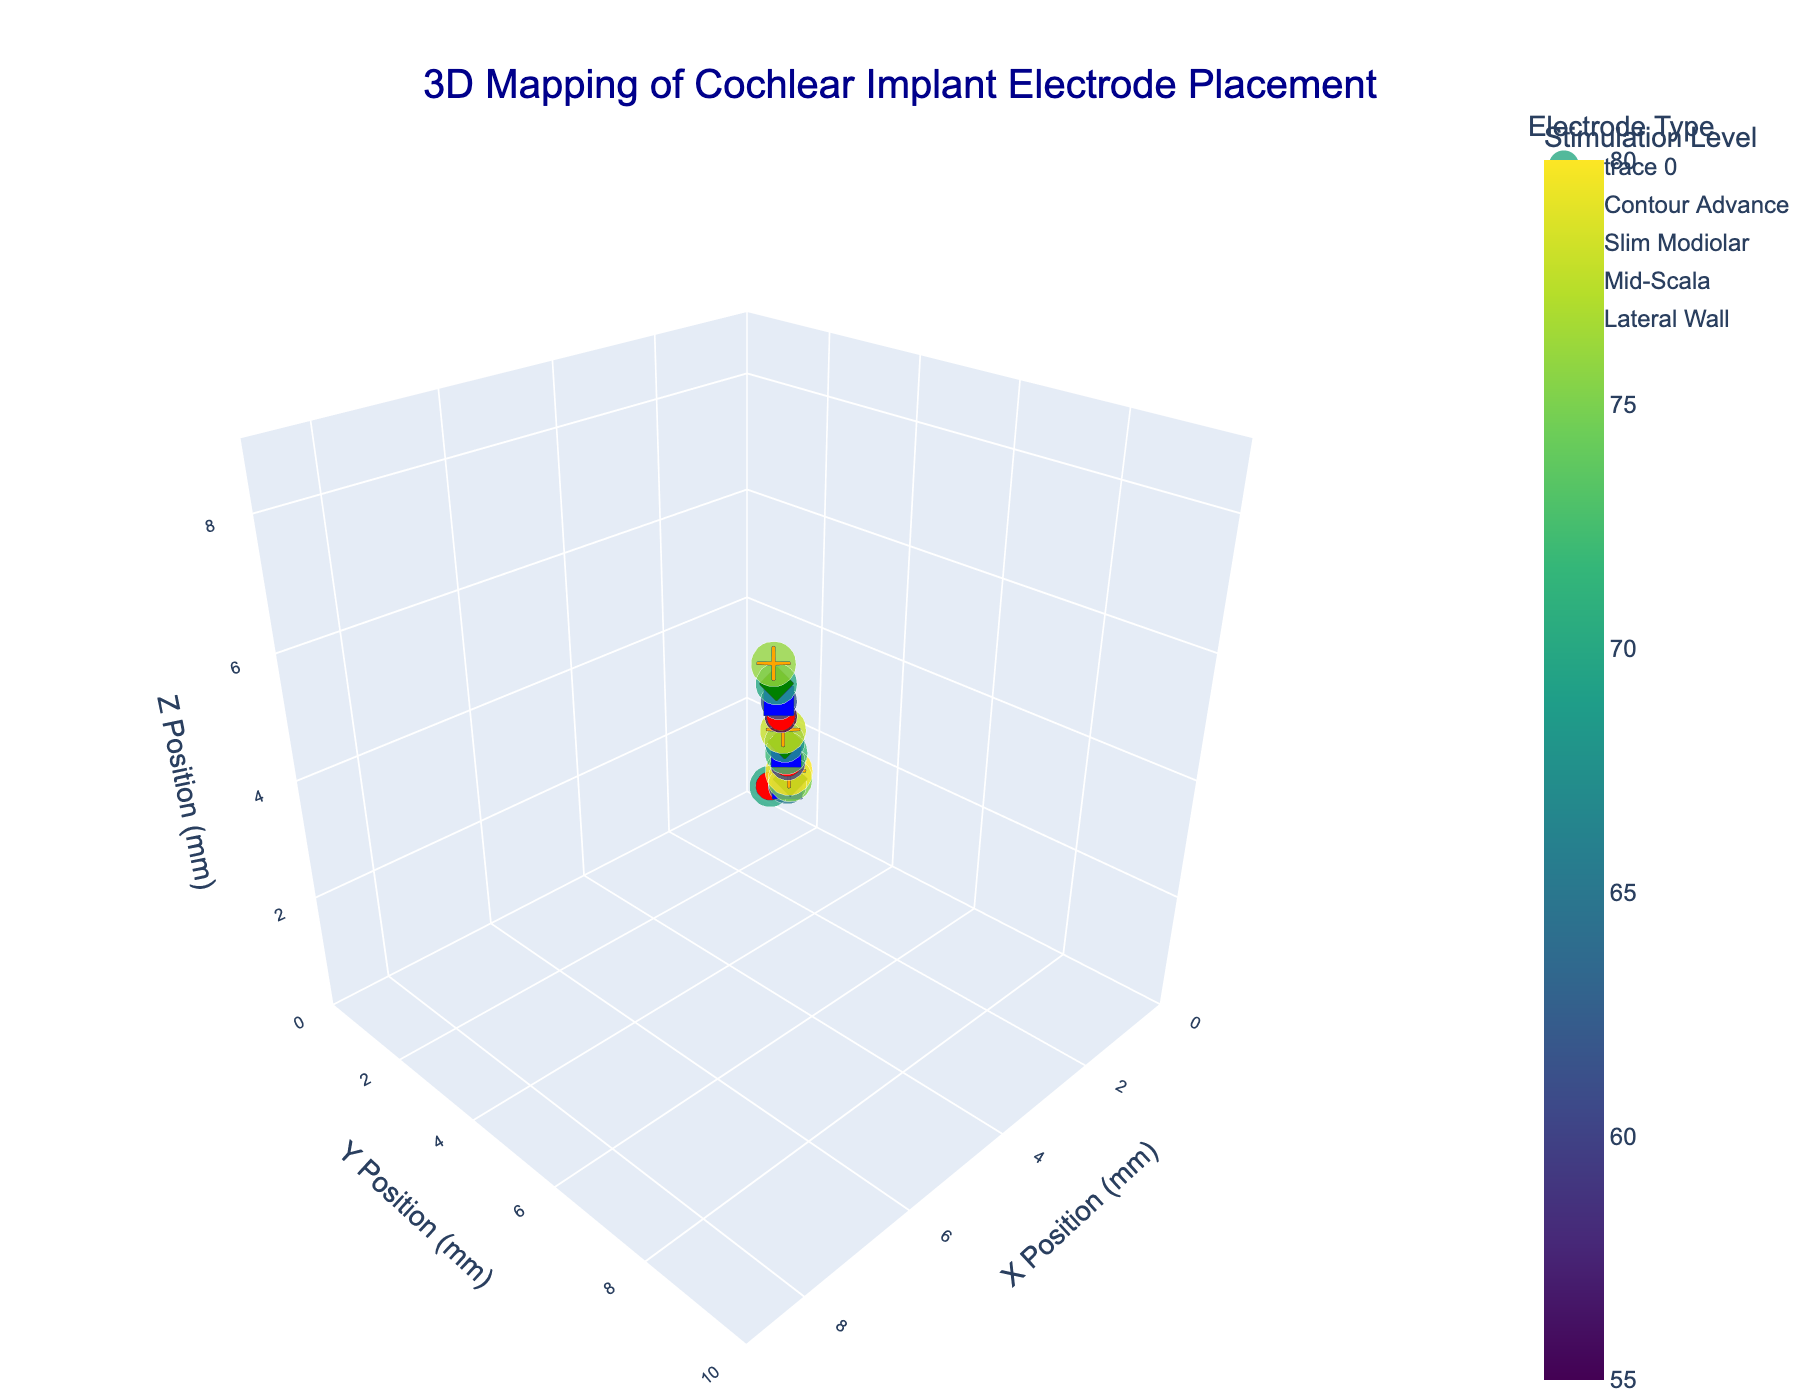How many unique electrode types are represented in the plot? The legend in the plot shows 4 unique symbols, each representing a different electrode type: Contour Advance, Slim Modiolar, Mid-Scala, and Lateral Wall.
Answer: 4 What is the title of the plot? The title is displayed at the top of the plot in a larger font size.
Answer: 3D Mapping of Cochlear Implant Electrode Placement Which electrode type has the highest stimulation level, and what is that level? By examining the color gradient and the hover text, we see that the Lateral Wall electrode has the highest stimulation level of 80.
Answer: Lateral Wall, 80 Between the Contour Advance and Slim Modiolar electrode types, which type has electrodes at higher stimulation levels on average? Adding the stimulation levels for each type and comparing the averages: Contour Advance (70 + 60 + 55) / 3 = 61.67, Slim Modiolar (65 + 72 + 62) / 3 = 66.33. Slim Modiolar has a higher average.
Answer: Slim Modiolar Where is the Mid-Scala electrode located in the plot at the position (7.4, 8.7, 7.8)? The plot shows coordinates of data points along x, y, and z axes. The Mid-Scala electrode can be identified at (7.4, 8.7, 7.8).
Answer: (7.4, 8.7, 7.8) Which axis represents the Y Position, and what is its range? The Y axis is identified as the vertical axis in the plot, labeled "Y Position (mm)" with a range from 0 to 10 as shown in the plot.
Answer: Y Position, 0-10 mm What electrode type has the largest spread in stimulation levels? Calculating the range for each type: Contour Advance (70-55=15), Slim Modiolar (72-62=10), Mid-Scala (75-68=7), Lateral Wall (80-76=4). Contour Advance has the largest spread.
Answer: Contour Advance How do the stimulation levels of Mid-Scala electrodes compare to those of Lateral Wall electrodes? By comparing their stimulation levels: Mid-Scala (75, 68, 70) and Lateral Wall (80, 78, 76). All Mid-Scala levels are lower than Lateral Wall levels.
Answer: Mid-Scala < Lateral Wall How many data points are in the plot? Each marker in the plot represents a data point. By counting the markers or summarizing from provided data, we find 12 data points.
Answer: 12 